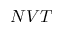<formula> <loc_0><loc_0><loc_500><loc_500>N V T</formula> 